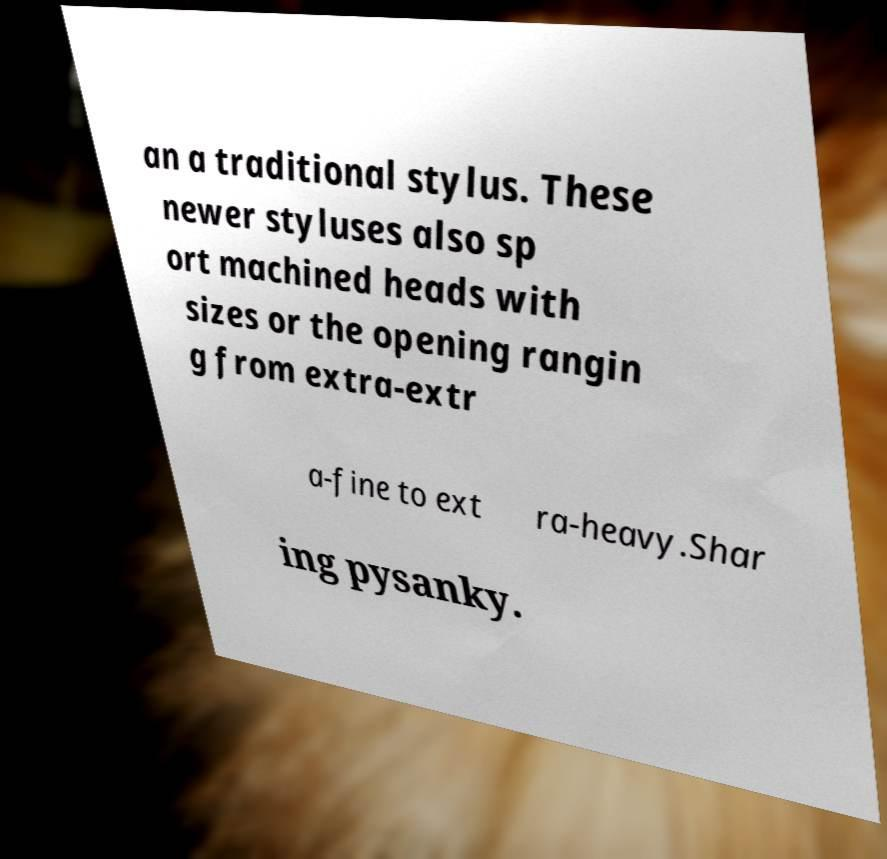I need the written content from this picture converted into text. Can you do that? an a traditional stylus. These newer styluses also sp ort machined heads with sizes or the opening rangin g from extra-extr a-fine to ext ra-heavy.Shar ing pysanky. 